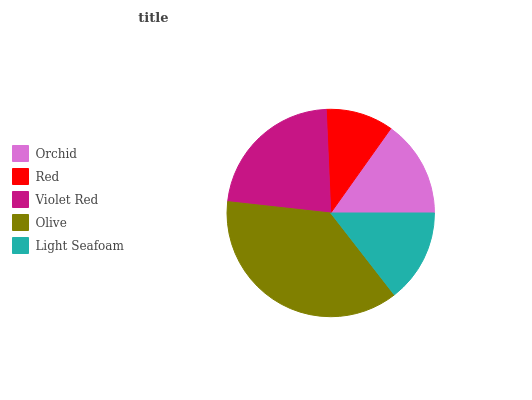Is Red the minimum?
Answer yes or no. Yes. Is Olive the maximum?
Answer yes or no. Yes. Is Violet Red the minimum?
Answer yes or no. No. Is Violet Red the maximum?
Answer yes or no. No. Is Violet Red greater than Red?
Answer yes or no. Yes. Is Red less than Violet Red?
Answer yes or no. Yes. Is Red greater than Violet Red?
Answer yes or no. No. Is Violet Red less than Red?
Answer yes or no. No. Is Orchid the high median?
Answer yes or no. Yes. Is Orchid the low median?
Answer yes or no. Yes. Is Light Seafoam the high median?
Answer yes or no. No. Is Violet Red the low median?
Answer yes or no. No. 